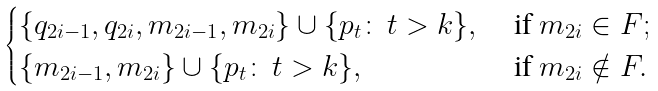<formula> <loc_0><loc_0><loc_500><loc_500>\begin{cases} \{ q _ { 2 i - 1 } , q _ { 2 i } , m _ { 2 i - 1 } , m _ { 2 i } \} \cup \{ p _ { t } \colon \, t > k \} , & \text { if } m _ { 2 i } \in F ; \\ \{ m _ { 2 i - 1 } , m _ { 2 i } \} \cup \{ p _ { t } \colon \, t > k \} , & \text { if } m _ { 2 i } \notin F . \end{cases}</formula> 